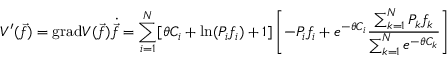Convert formula to latex. <formula><loc_0><loc_0><loc_500><loc_500>V ^ { \prime } ( \vec { f } ) = g r a d V ( \vec { f } ) \dot { \vec { f } } = \sum _ { i = 1 } ^ { N } [ \theta C _ { i } + \ln ( P _ { i } f _ { i } ) + 1 ] \left [ - P _ { i } f _ { i } + e ^ { - \theta C _ { i } } \frac { \sum _ { k = 1 } ^ { N } P _ { k } f _ { k } } { \sum _ { k = 1 } ^ { N } e ^ { - \theta C _ { k } } } \right ]</formula> 